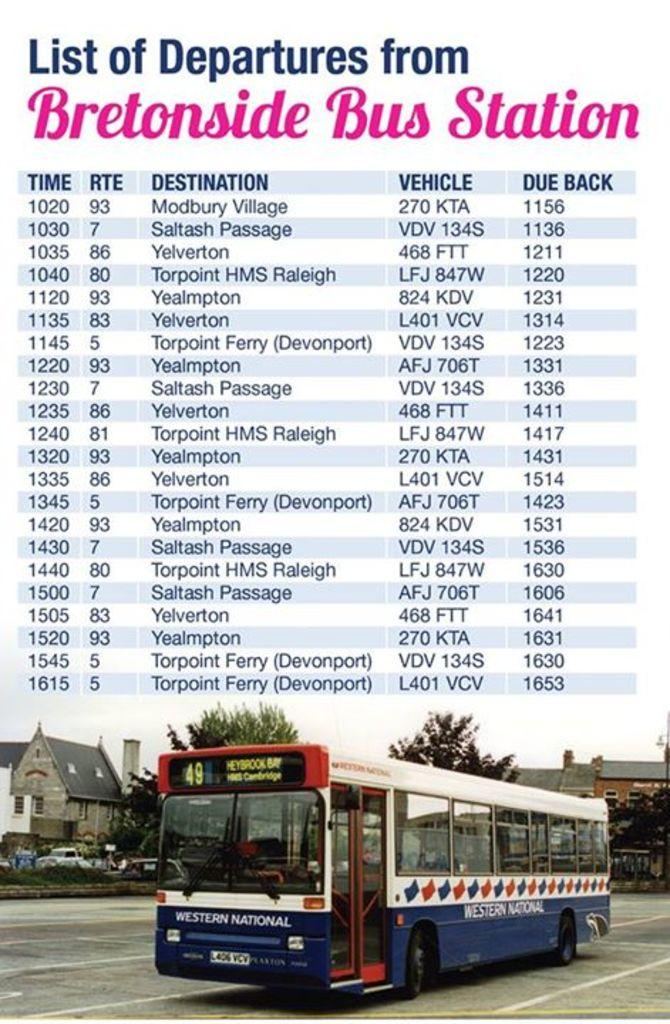What is featured in the image? There is a poster in the image. What is depicted on the poster? The poster depicts a bus on the road. What additional information is provided on the poster? There are bus routes with their bus numbers above the bus in the poster. What can be seen in the background of the bus in the poster? There are houses and trees behind the bus in the poster. How does the brain help the bus navigate through the rainstorm in the image? There is no brain or rainstorm depicted in the image; it features a poster with a bus on the road and additional information about bus routes. 